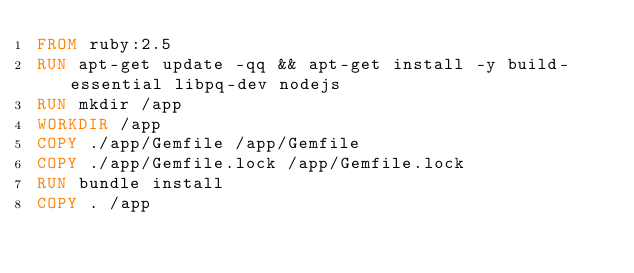<code> <loc_0><loc_0><loc_500><loc_500><_Dockerfile_>FROM ruby:2.5
RUN apt-get update -qq && apt-get install -y build-essential libpq-dev nodejs
RUN mkdir /app
WORKDIR /app
COPY ./app/Gemfile /app/Gemfile
COPY ./app/Gemfile.lock /app/Gemfile.lock
RUN bundle install
COPY . /app
</code> 